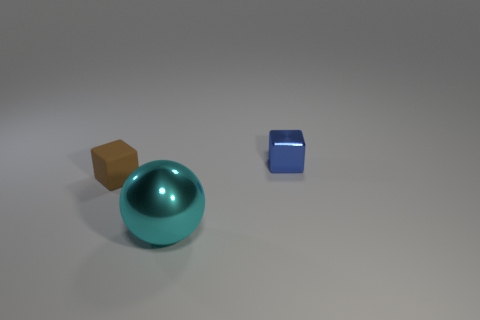Is there anything else that has the same shape as the big cyan object?
Provide a succinct answer. No. What number of metal blocks are in front of the small cube on the right side of the large sphere?
Ensure brevity in your answer.  0. Is there any other thing that is the same material as the small brown block?
Give a very brief answer. No. What number of objects are either tiny blocks to the left of the blue metallic thing or red cubes?
Provide a short and direct response. 1. What is the size of the metal thing that is in front of the tiny matte object?
Provide a short and direct response. Large. What is the material of the small blue cube?
Provide a short and direct response. Metal. There is a metallic object behind the object left of the large ball; what is its shape?
Provide a short and direct response. Cube. How many other things are there of the same shape as the small brown rubber object?
Provide a succinct answer. 1. There is a tiny brown cube; are there any tiny matte things behind it?
Make the answer very short. No. The ball has what color?
Provide a succinct answer. Cyan. 